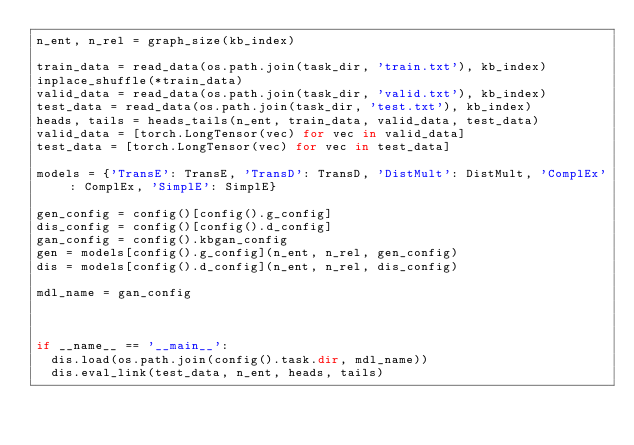Convert code to text. <code><loc_0><loc_0><loc_500><loc_500><_Python_>n_ent, n_rel = graph_size(kb_index)

train_data = read_data(os.path.join(task_dir, 'train.txt'), kb_index)
inplace_shuffle(*train_data)
valid_data = read_data(os.path.join(task_dir, 'valid.txt'), kb_index)
test_data = read_data(os.path.join(task_dir, 'test.txt'), kb_index)
heads, tails = heads_tails(n_ent, train_data, valid_data, test_data)
valid_data = [torch.LongTensor(vec) for vec in valid_data]
test_data = [torch.LongTensor(vec) for vec in test_data]

models = {'TransE': TransE, 'TransD': TransD, 'DistMult': DistMult, 'ComplEx': ComplEx, 'SimplE': SimplE}

gen_config = config()[config().g_config]
dis_config = config()[config().d_config]
gan_config = config().kbgan_config
gen = models[config().g_config](n_ent, n_rel, gen_config)
dis = models[config().d_config](n_ent, n_rel, dis_config)

mdl_name = gan_config



if __name__ == '__main__':
  dis.load(os.path.join(config().task.dir, mdl_name))
  dis.eval_link(test_data, n_ent, heads, tails)</code> 